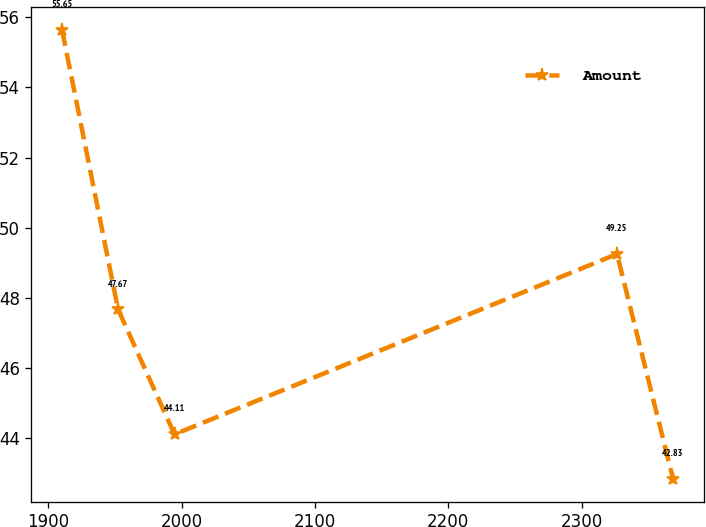<chart> <loc_0><loc_0><loc_500><loc_500><line_chart><ecel><fcel>Amount<nl><fcel>1910.17<fcel>55.65<nl><fcel>1952.26<fcel>47.67<nl><fcel>1994.61<fcel>44.11<nl><fcel>2326.6<fcel>49.25<nl><fcel>2368.69<fcel>42.83<nl></chart> 